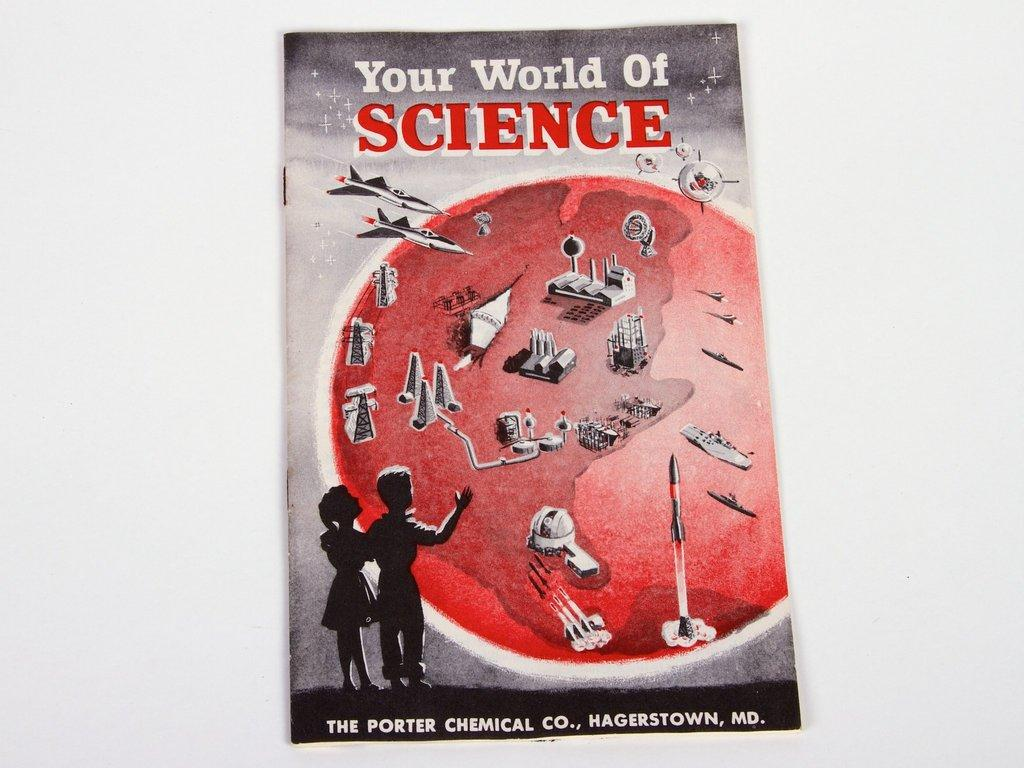<image>
Write a terse but informative summary of the picture. a booklet that has the title 'your world of science' at the top 